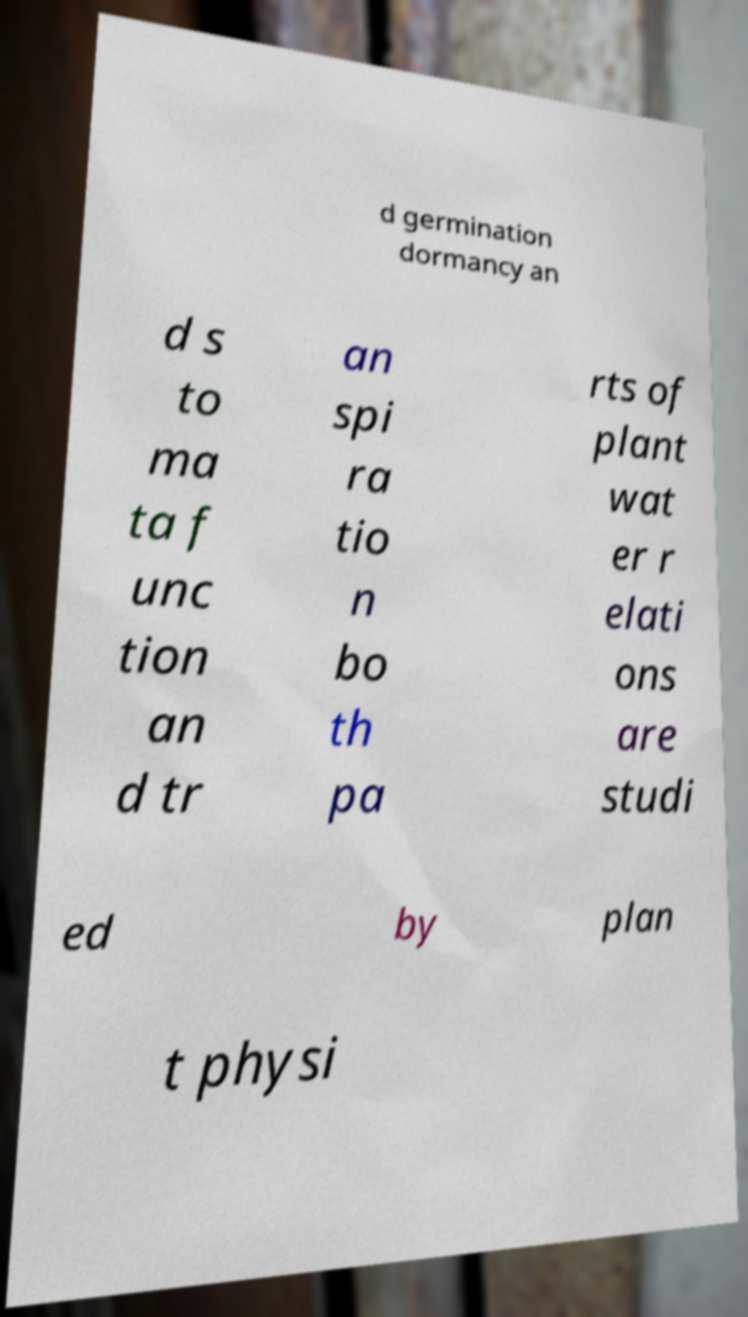There's text embedded in this image that I need extracted. Can you transcribe it verbatim? d germination dormancy an d s to ma ta f unc tion an d tr an spi ra tio n bo th pa rts of plant wat er r elati ons are studi ed by plan t physi 